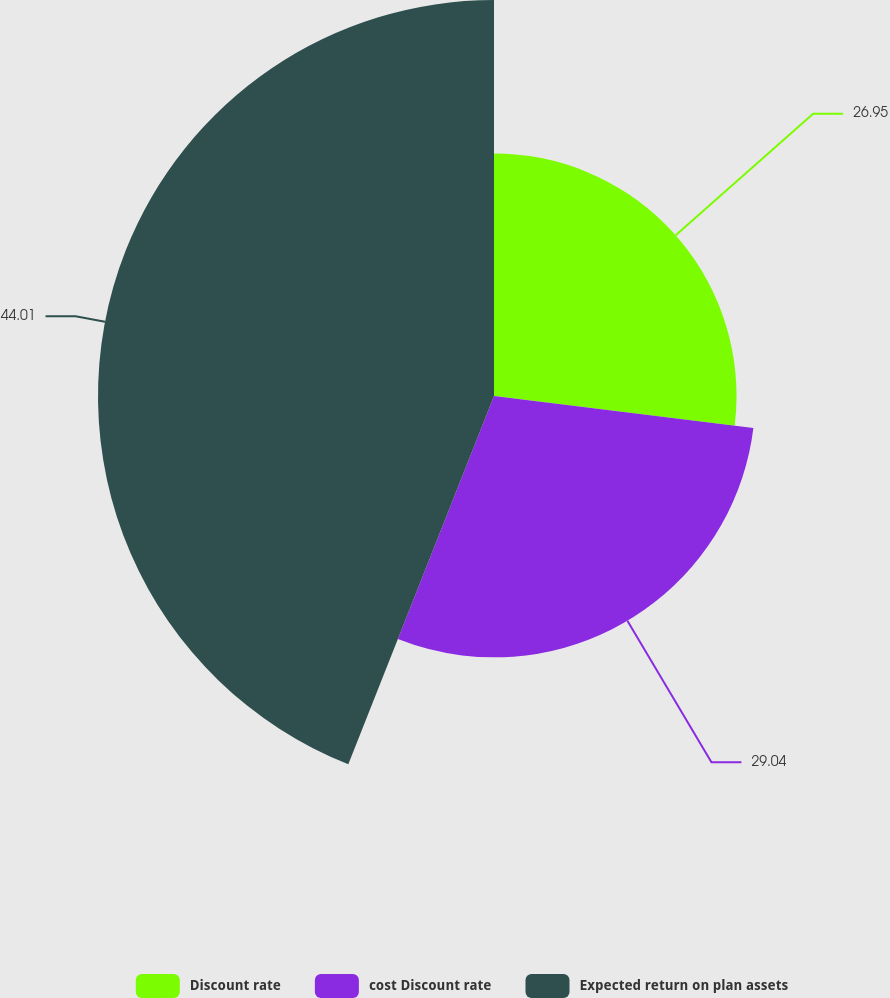<chart> <loc_0><loc_0><loc_500><loc_500><pie_chart><fcel>Discount rate<fcel>cost Discount rate<fcel>Expected return on plan assets<nl><fcel>26.95%<fcel>29.04%<fcel>44.0%<nl></chart> 